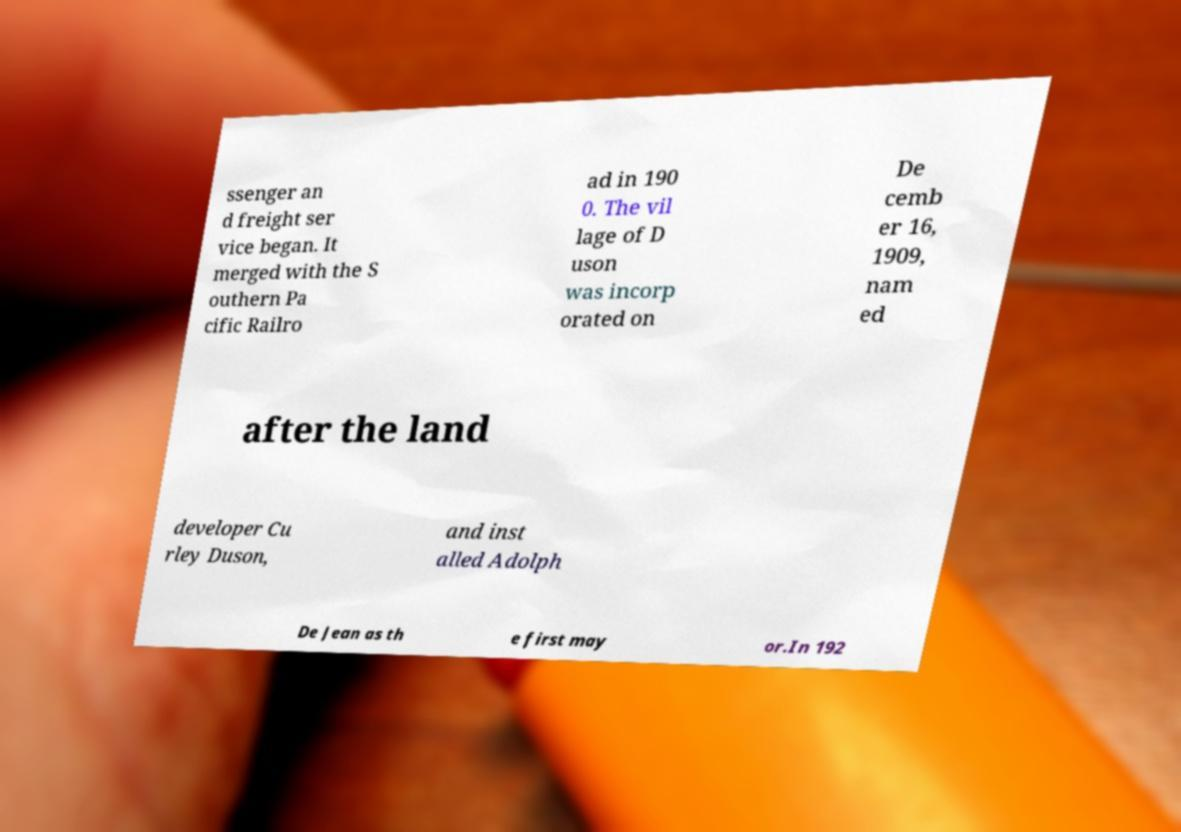Could you extract and type out the text from this image? ssenger an d freight ser vice began. It merged with the S outhern Pa cific Railro ad in 190 0. The vil lage of D uson was incorp orated on De cemb er 16, 1909, nam ed after the land developer Cu rley Duson, and inst alled Adolph De Jean as th e first may or.In 192 